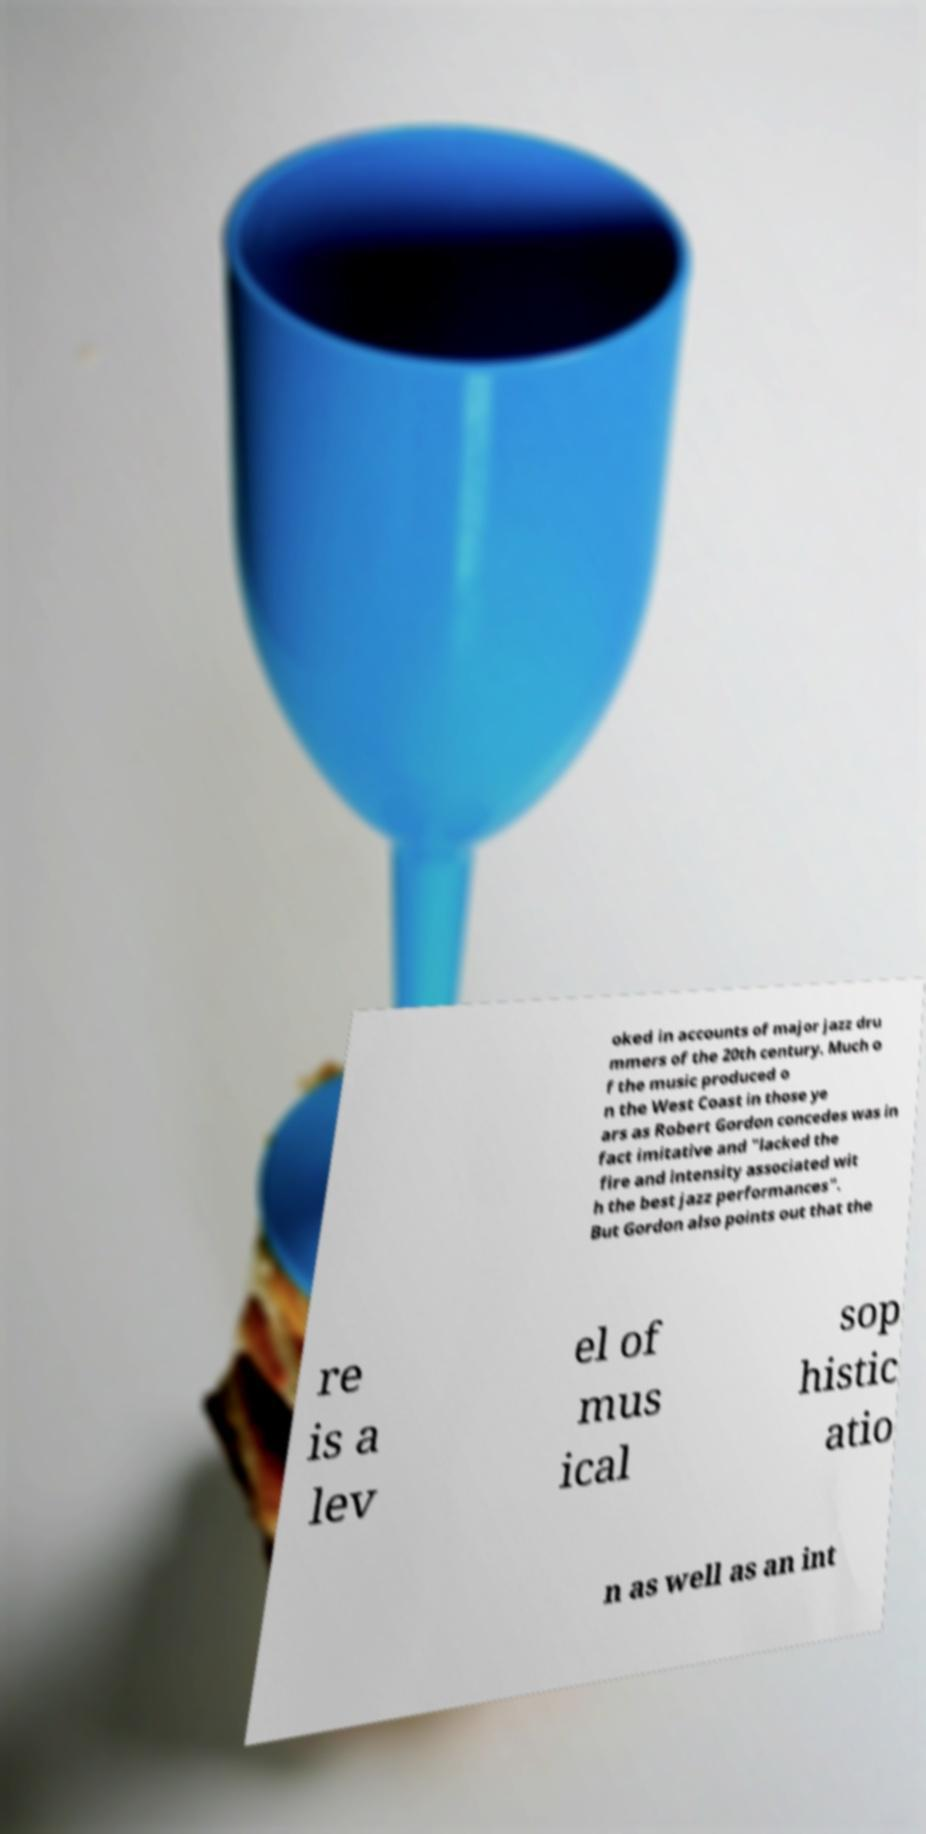Please read and relay the text visible in this image. What does it say? oked in accounts of major jazz dru mmers of the 20th century. Much o f the music produced o n the West Coast in those ye ars as Robert Gordon concedes was in fact imitative and "lacked the fire and intensity associated wit h the best jazz performances". But Gordon also points out that the re is a lev el of mus ical sop histic atio n as well as an int 